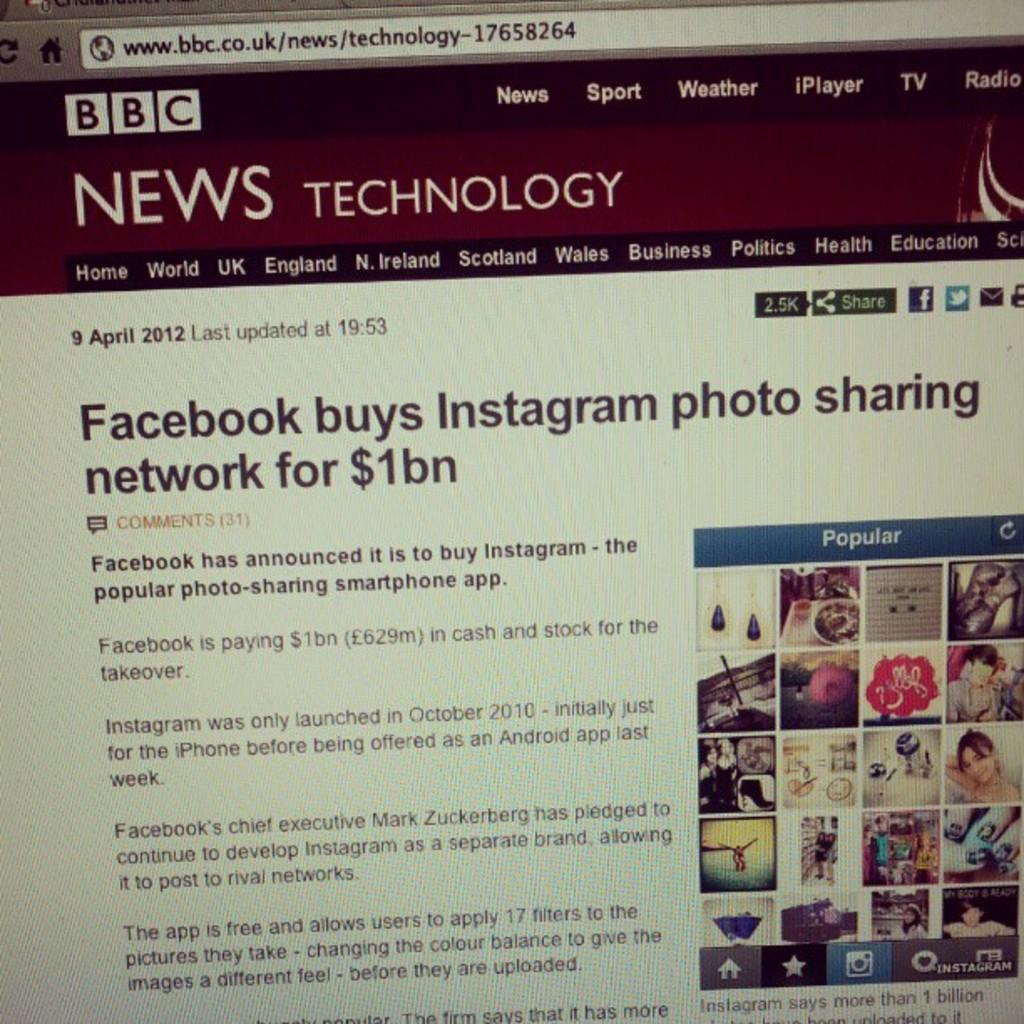<image>
Share a concise interpretation of the image provided. A computer screen showing an article about Facebook buying Instagram. 